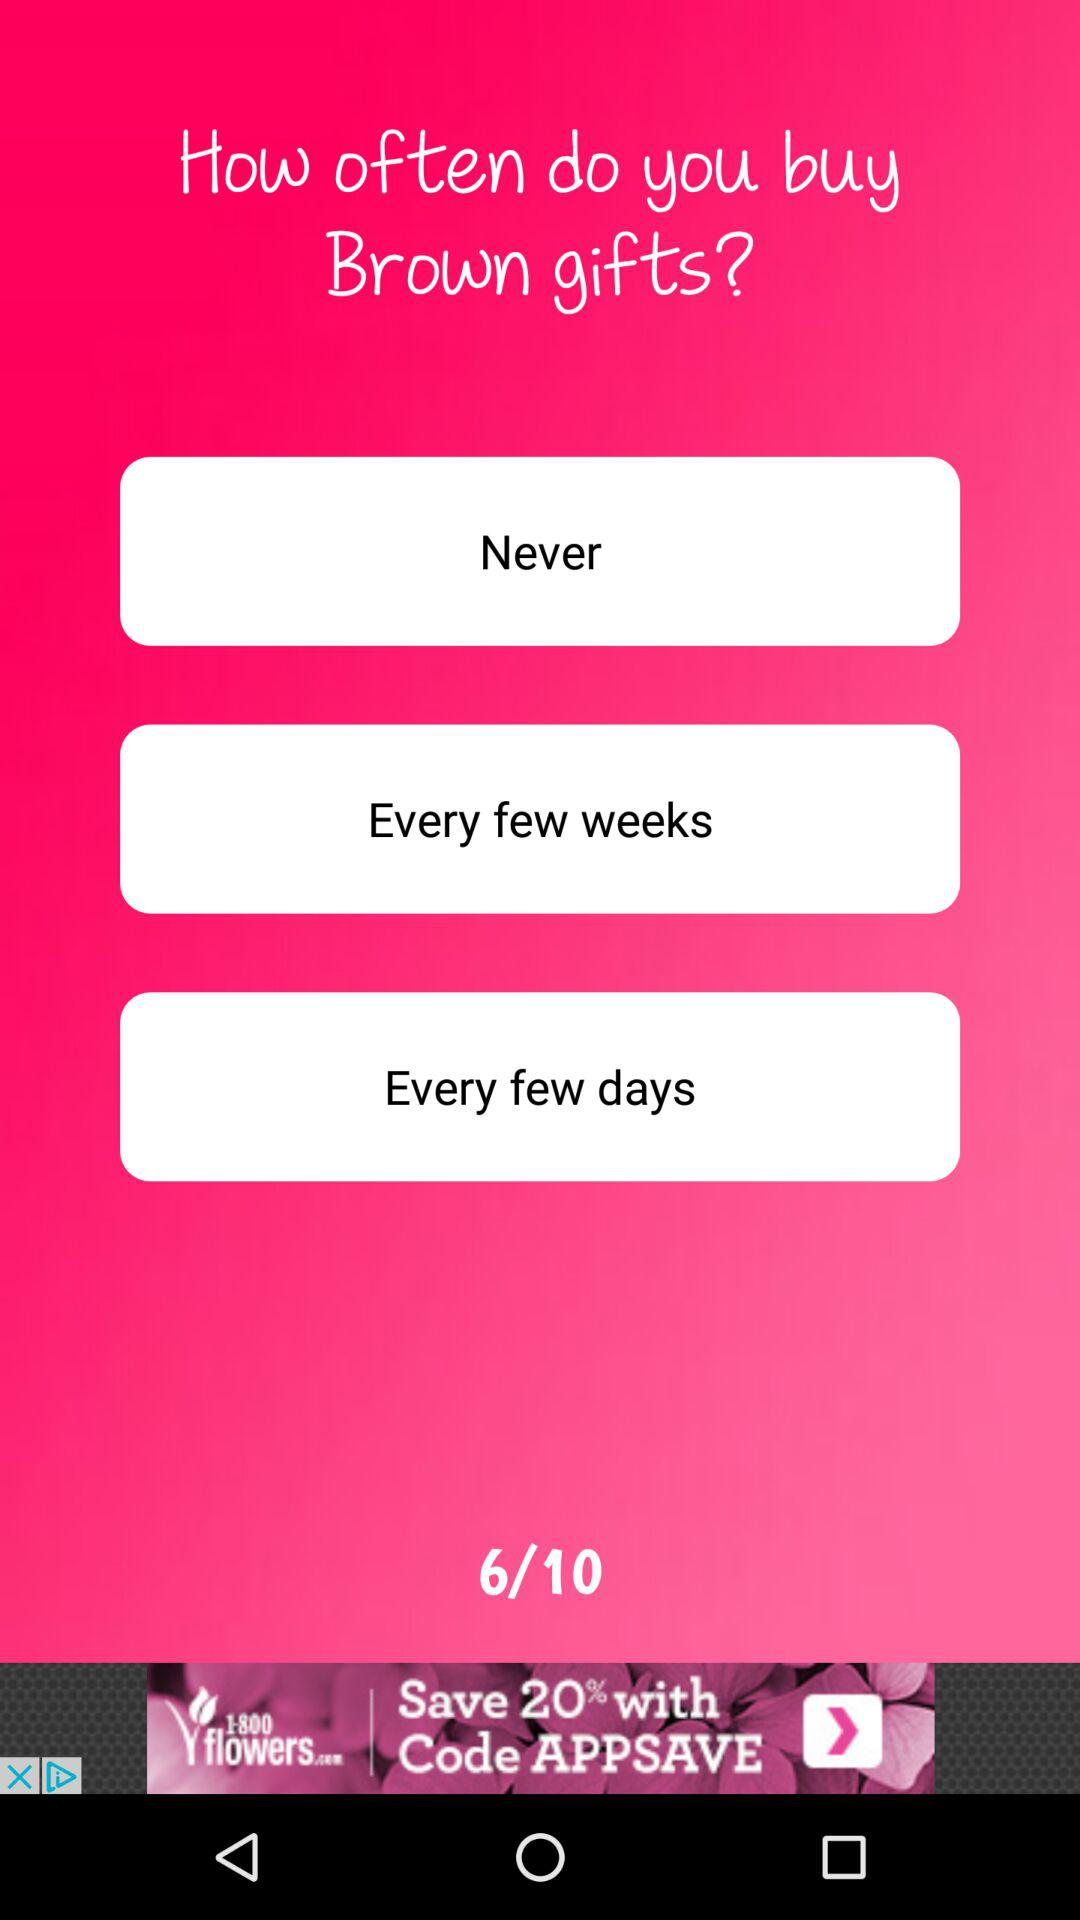How many questions are there in total? There are 10 questions in total. 